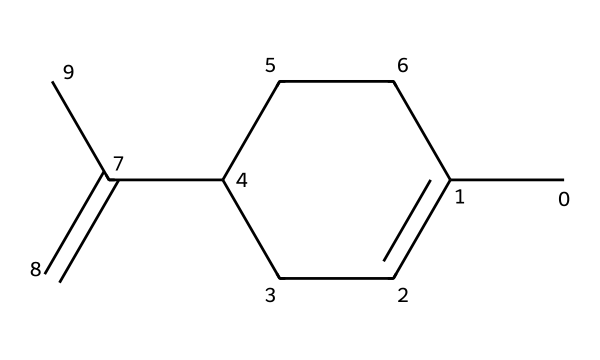What is the molecular formula of limonene? Counting the number of carbon (C) and hydrogen (H) atoms in the SMILES, there are 10 carbon atoms and 16 hydrogen atoms. Therefore, the molecular formula is C10H16.
Answer: C10H16 How many rings are present in limonene? By analyzing the SMILES representation, we see that the 'C1' notation indicates a cyclic structure, and all atoms support one ring. Hence, there is one ring.
Answer: one Does limonene contain any double bonds? In the SMILES, the 'C=C' notation indicates the presence of a double bond in the molecular structure. Therefore, there is at least one double bond present.
Answer: yes What type of cycloalkane is limonene? Limonene is classified as a cyclic terpene due to its structure consisting of a cycloalkane with a double bond and its natural abundance in aromatic plants.
Answer: terpene How many substituents are attached to the ring in limonene? Analyzing the molecule, we observe one methyl group (–CH3) and one propenyl group (–C=C) are directly bonded to the ring structure. Thus, there are two substituents attached.
Answer: two What is the primary functional group in limonene? The presence of a double bond indicates that limonene primarily contains an alkene functional group within its structure, typical in cycloalkanes.
Answer: alkene 